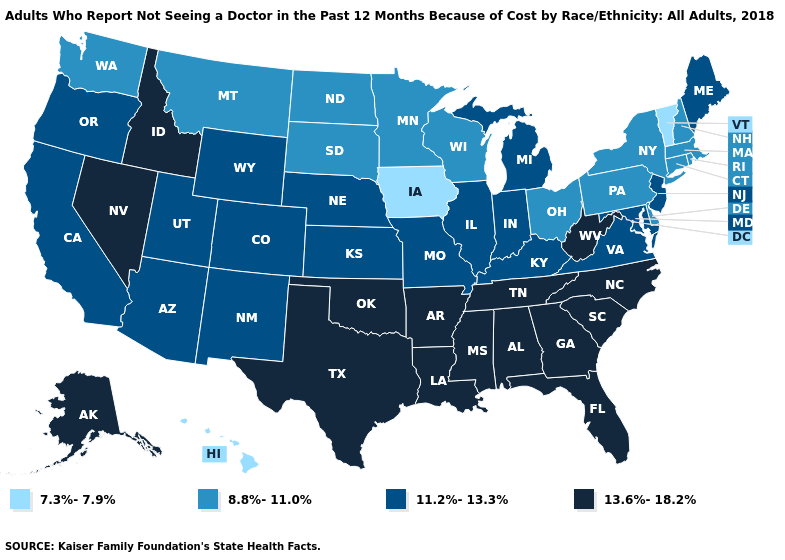Name the states that have a value in the range 13.6%-18.2%?
Concise answer only. Alabama, Alaska, Arkansas, Florida, Georgia, Idaho, Louisiana, Mississippi, Nevada, North Carolina, Oklahoma, South Carolina, Tennessee, Texas, West Virginia. What is the value of Alabama?
Answer briefly. 13.6%-18.2%. Does the map have missing data?
Give a very brief answer. No. Does Hawaii have the lowest value in the USA?
Answer briefly. Yes. Name the states that have a value in the range 13.6%-18.2%?
Write a very short answer. Alabama, Alaska, Arkansas, Florida, Georgia, Idaho, Louisiana, Mississippi, Nevada, North Carolina, Oklahoma, South Carolina, Tennessee, Texas, West Virginia. Name the states that have a value in the range 13.6%-18.2%?
Quick response, please. Alabama, Alaska, Arkansas, Florida, Georgia, Idaho, Louisiana, Mississippi, Nevada, North Carolina, Oklahoma, South Carolina, Tennessee, Texas, West Virginia. What is the lowest value in states that border Delaware?
Keep it brief. 8.8%-11.0%. Does Kansas have the same value as Ohio?
Give a very brief answer. No. Among the states that border Kentucky , does Ohio have the highest value?
Write a very short answer. No. Among the states that border New York , which have the lowest value?
Write a very short answer. Vermont. What is the value of Illinois?
Give a very brief answer. 11.2%-13.3%. Which states hav the highest value in the Northeast?
Answer briefly. Maine, New Jersey. What is the value of Vermont?
Write a very short answer. 7.3%-7.9%. Which states hav the highest value in the Northeast?
Keep it brief. Maine, New Jersey. What is the lowest value in the USA?
Answer briefly. 7.3%-7.9%. 